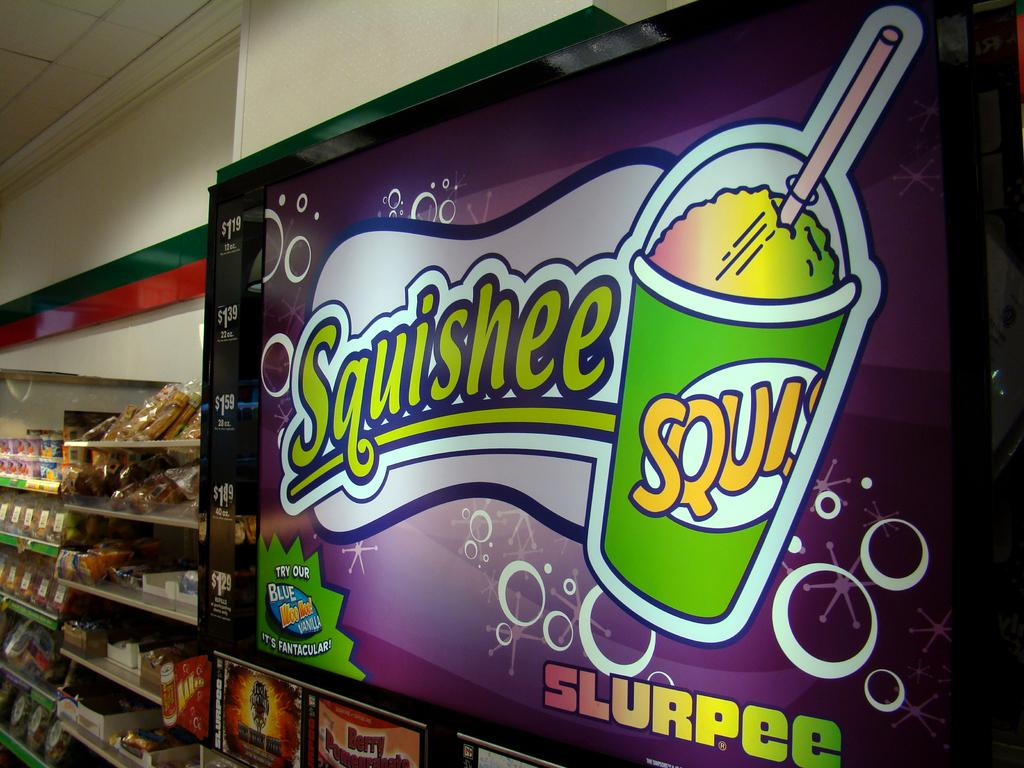<image>
Create a compact narrative representing the image presented. Squishee slurpee sign in a store that is above the slurpee machine 